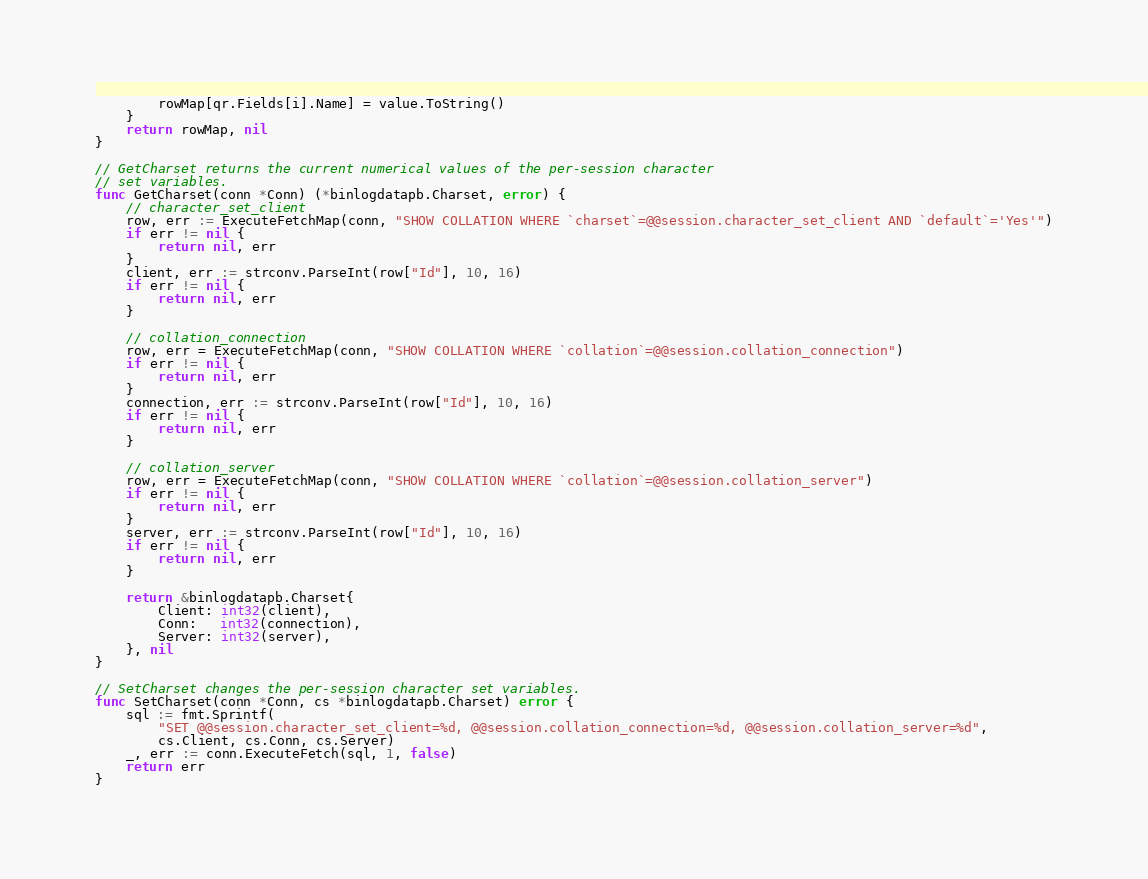Convert code to text. <code><loc_0><loc_0><loc_500><loc_500><_Go_>		rowMap[qr.Fields[i].Name] = value.ToString()
	}
	return rowMap, nil
}

// GetCharset returns the current numerical values of the per-session character
// set variables.
func GetCharset(conn *Conn) (*binlogdatapb.Charset, error) {
	// character_set_client
	row, err := ExecuteFetchMap(conn, "SHOW COLLATION WHERE `charset`=@@session.character_set_client AND `default`='Yes'")
	if err != nil {
		return nil, err
	}
	client, err := strconv.ParseInt(row["Id"], 10, 16)
	if err != nil {
		return nil, err
	}

	// collation_connection
	row, err = ExecuteFetchMap(conn, "SHOW COLLATION WHERE `collation`=@@session.collation_connection")
	if err != nil {
		return nil, err
	}
	connection, err := strconv.ParseInt(row["Id"], 10, 16)
	if err != nil {
		return nil, err
	}

	// collation_server
	row, err = ExecuteFetchMap(conn, "SHOW COLLATION WHERE `collation`=@@session.collation_server")
	if err != nil {
		return nil, err
	}
	server, err := strconv.ParseInt(row["Id"], 10, 16)
	if err != nil {
		return nil, err
	}

	return &binlogdatapb.Charset{
		Client: int32(client),
		Conn:   int32(connection),
		Server: int32(server),
	}, nil
}

// SetCharset changes the per-session character set variables.
func SetCharset(conn *Conn, cs *binlogdatapb.Charset) error {
	sql := fmt.Sprintf(
		"SET @@session.character_set_client=%d, @@session.collation_connection=%d, @@session.collation_server=%d",
		cs.Client, cs.Conn, cs.Server)
	_, err := conn.ExecuteFetch(sql, 1, false)
	return err
}
</code> 